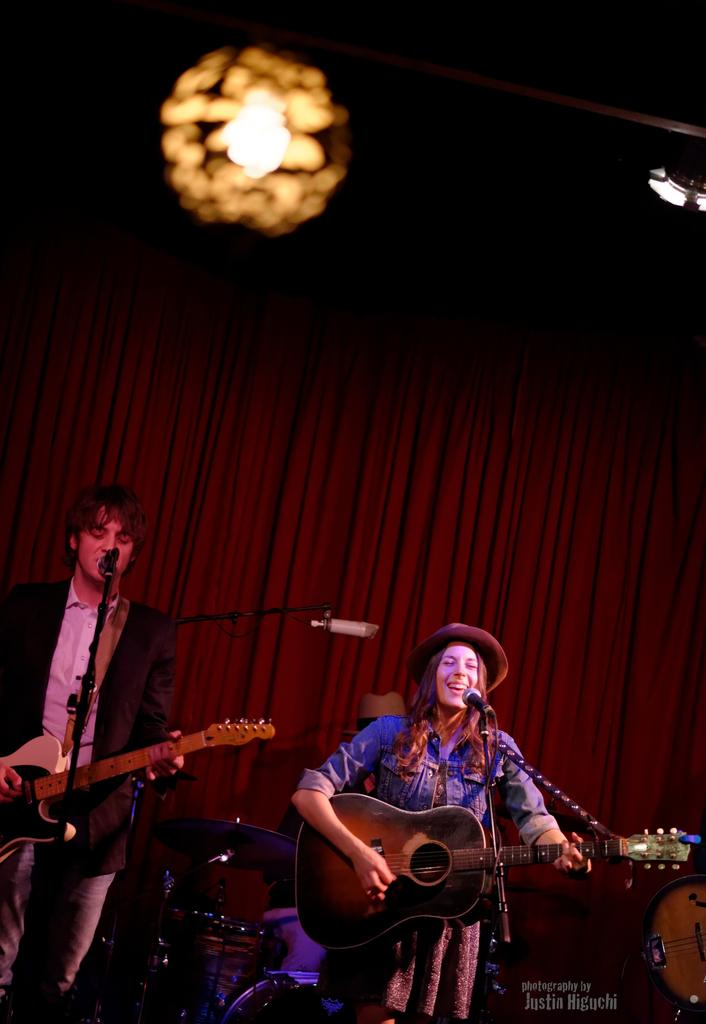How many people are in the image? There are two persons in the image. What are the two persons doing? They are playing a guitar. What object are they standing in front of? They are in front of a microphone. What color is the curtain in the image? There is a red curtain in the image. What can be seen at the top of the image? There is a light visible at the top of the image. What type of objects are present in the image that are related to music? Musical instruments are present in the image. What type of needle is being used to connect the two persons in the image? There is no needle or connection between the two persons in the image; they are simply playing a guitar in front of a microphone. 